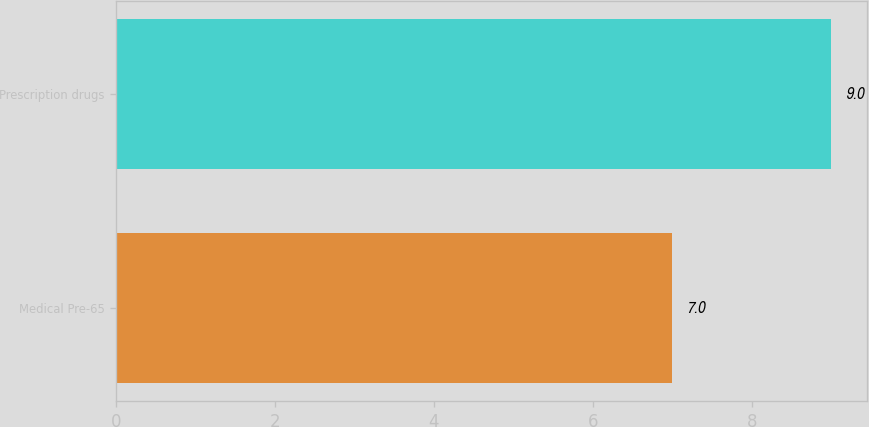<chart> <loc_0><loc_0><loc_500><loc_500><bar_chart><fcel>Medical Pre-65<fcel>Prescription drugs<nl><fcel>7<fcel>9<nl></chart> 